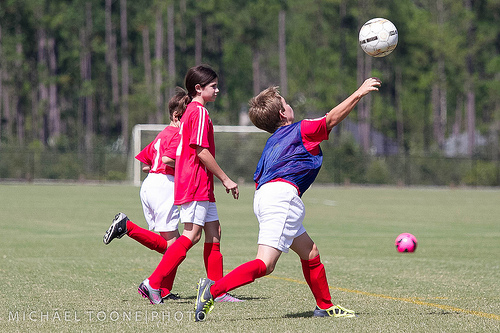<image>
Is the boy under the ball? Yes. The boy is positioned underneath the ball, with the ball above it in the vertical space. Is there a boy behind the ball? Yes. From this viewpoint, the boy is positioned behind the ball, with the ball partially or fully occluding the boy. Is the soccer ball above the soccer player? Yes. The soccer ball is positioned above the soccer player in the vertical space, higher up in the scene. 